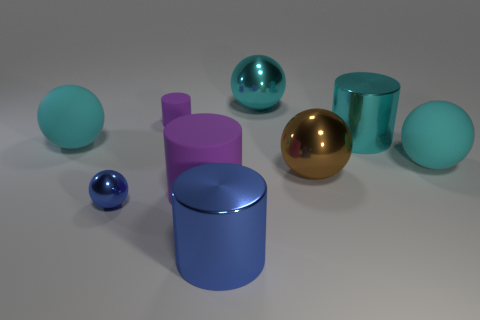Do the big cyan cylinder and the blue cylinder have the same material?
Give a very brief answer. Yes. What material is the tiny object behind the metal cylinder that is to the right of the brown thing?
Provide a succinct answer. Rubber. Is the number of big cyan shiny things in front of the brown object greater than the number of large blue cylinders?
Give a very brief answer. No. How many other things are the same size as the brown thing?
Your answer should be very brief. 6. Is the tiny rubber cylinder the same color as the tiny shiny object?
Give a very brief answer. No. There is a shiny thing in front of the blue metal thing behind the large shiny cylinder that is to the left of the cyan shiny sphere; what color is it?
Make the answer very short. Blue. What number of large blue objects are to the right of the purple object that is in front of the big cyan rubber object to the right of the large brown object?
Keep it short and to the point. 1. Is there anything else that is the same color as the small shiny object?
Give a very brief answer. Yes. Is the size of the cyan rubber object right of the brown metal sphere the same as the big blue cylinder?
Provide a succinct answer. Yes. There is a blue thing that is to the right of the tiny shiny object; what number of metal cylinders are on the left side of it?
Your response must be concise. 0. 